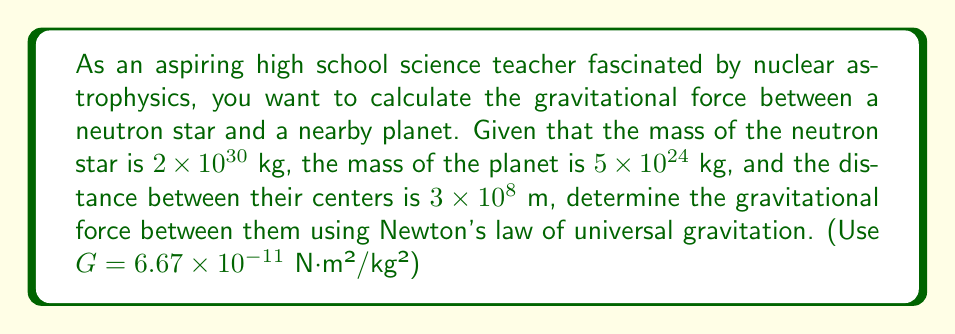Show me your answer to this math problem. To solve this problem, we'll use Newton's law of universal gravitation:

$$ F = G \frac{m_1 m_2}{r^2} $$

Where:
$F$ is the gravitational force between the two bodies
$G$ is the gravitational constant ($6.67 \times 10^{-11}$ N⋅m²/kg²)
$m_1$ is the mass of the first body (neutron star)
$m_2$ is the mass of the second body (planet)
$r$ is the distance between the centers of the two bodies

Let's substitute the given values:

$m_1 = 2 \times 10^{30}$ kg (neutron star)
$m_2 = 5 \times 10^{24}$ kg (planet)
$r = 3 \times 10^{8}$ m
$G = 6.67 \times 10^{-11}$ N⋅m²/kg²

Now, let's calculate:

$$ F = (6.67 \times 10^{-11}) \frac{(2 \times 10^{30})(5 \times 10^{24})}{(3 \times 10^{8})^2} $$

$$ F = (6.67 \times 10^{-11}) \frac{10 \times 10^{54}}{9 \times 10^{16}} $$

$$ F = (6.67 \times 10^{-11}) \times \frac{10}{9} \times 10^{38} $$

$$ F = 7.41 \times 10^{27} \text{ N} $$

Therefore, the gravitational force between the neutron star and the planet is approximately $7.41 \times 10^{27}$ N.
Answer: $7.41 \times 10^{27}$ N 